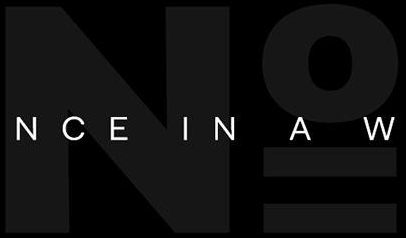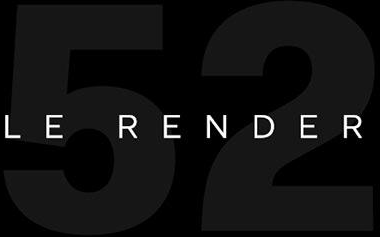What text appears in these images from left to right, separated by a semicolon? No; 52 